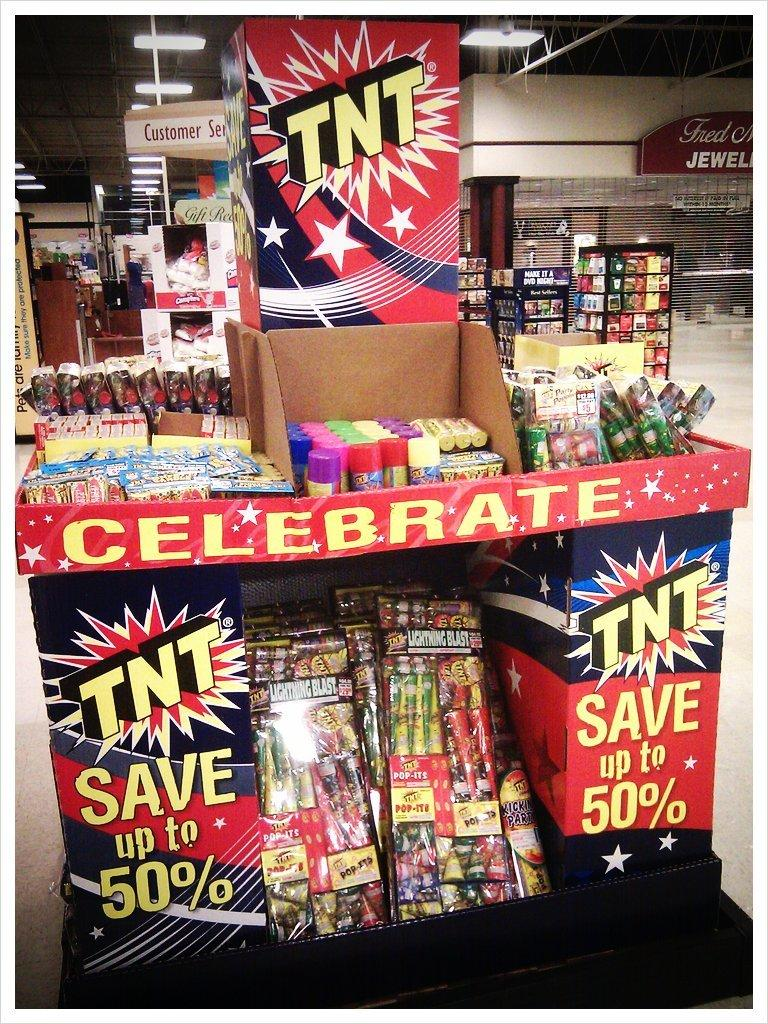<image>
Share a concise interpretation of the image provided. A TNT firework display with several different kinds of fireworks for sell. 